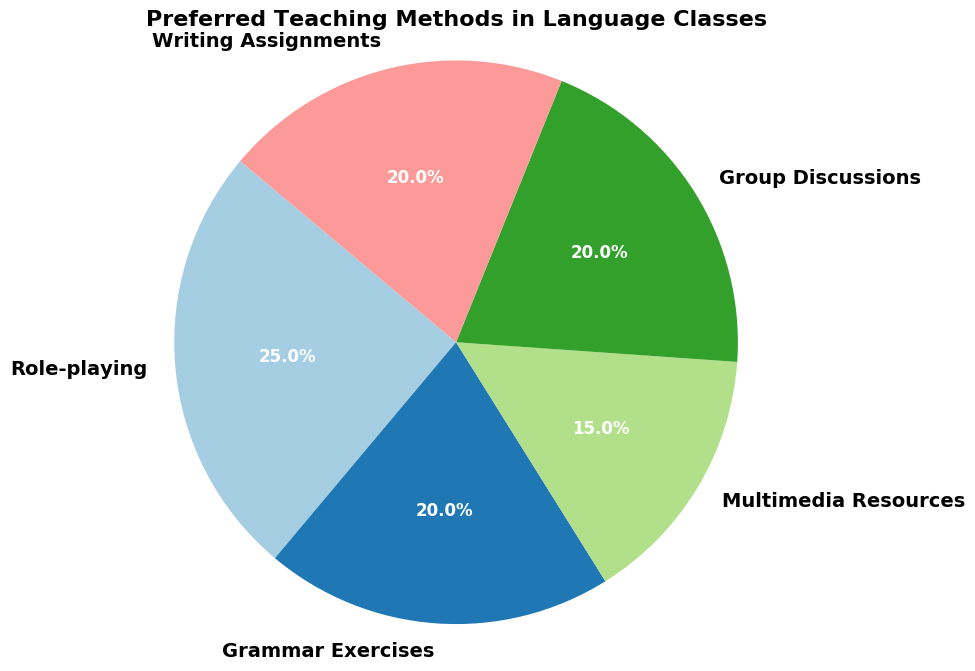What proportion of the methods fall within the range 20%-25%? To find the proportion, first identify which methods fall within the range of 20%-25%. Grammar Exercises, Group Discussions, and Writing Assignments each account for 20%, and Role-playing accounts for 25%. There are 3 methods at 20% and 1 method at 25%, so 4 out of 5 methods fall within the range. Proportion = (4/5) * 100% = 80%.
Answer: 80% Which method has the highest percentage? By observing the pie chart, Role-playing has the highest percentage at 25%.
Answer: Role-playing How do the percentages of Grammar Exercises and Writing Assignments compare? Both Grammar Exercises and Writing Assignments have the same percentage, which is 20%.
Answer: They are equal What is the combined percentage of Multimedia Resources and Group Discussions? To find the combined percentage, add the percentages of Multimedia Resources (15%) and Group Discussions (20%). So, the combined percentage is 15% + 20% = 35%.
Answer: 35% Is there any method that has a smaller percentage than Multimedia Resources? Reviewing the pie chart, Multimedia Resources has the smallest percentage at 15%, so no other method has a smaller percentage.
Answer: No How many methods have a percentage that is equal to or higher than 20%? The methods with percentages equal to or higher than 20% are Role-playing (25%), Grammar Exercises (20%), Group Discussions (20%), and Writing Assignments (20%). That equals 4 methods.
Answer: 4 Which color in the pie chart represents Multimedia Resources? When observing the chart, Multimedia Resources is usually represented by the unique color allocated in the chart legend or description, in this case, it is light blue for this chart.
Answer: Light blue If you combine the percentages of all methods besides Role-playing, what is the outcome? Add the percentages of all the methods except Role-playing: Grammar Exercises (20%), Multimedia Resources (15%), Group Discussions (20%), and Writing Assignments (20%). The sum is 20% + 15% + 20% + 20% = 75%.
Answer: 75% What is the percentage difference between Role-playing and Multimedia Resources? To find the difference, subtract the percentage of Multimedia Resources (15%) from Role-playing (25%). The difference is 25% - 15% = 10%.
Answer: 10% What's the average percentage for all the teaching methods? To find the average percentage, add all the percentages: Role-playing (25%), Grammar Exercises (20%), Multimedia Resources (15%), Group Discussions (20%), Writing Assignments (20%), and divide by the number of methods (5). The average is (25% + 20% + 15% + 20% + 20%) / 5 = 100% / 5 = 20%.
Answer: 20% 